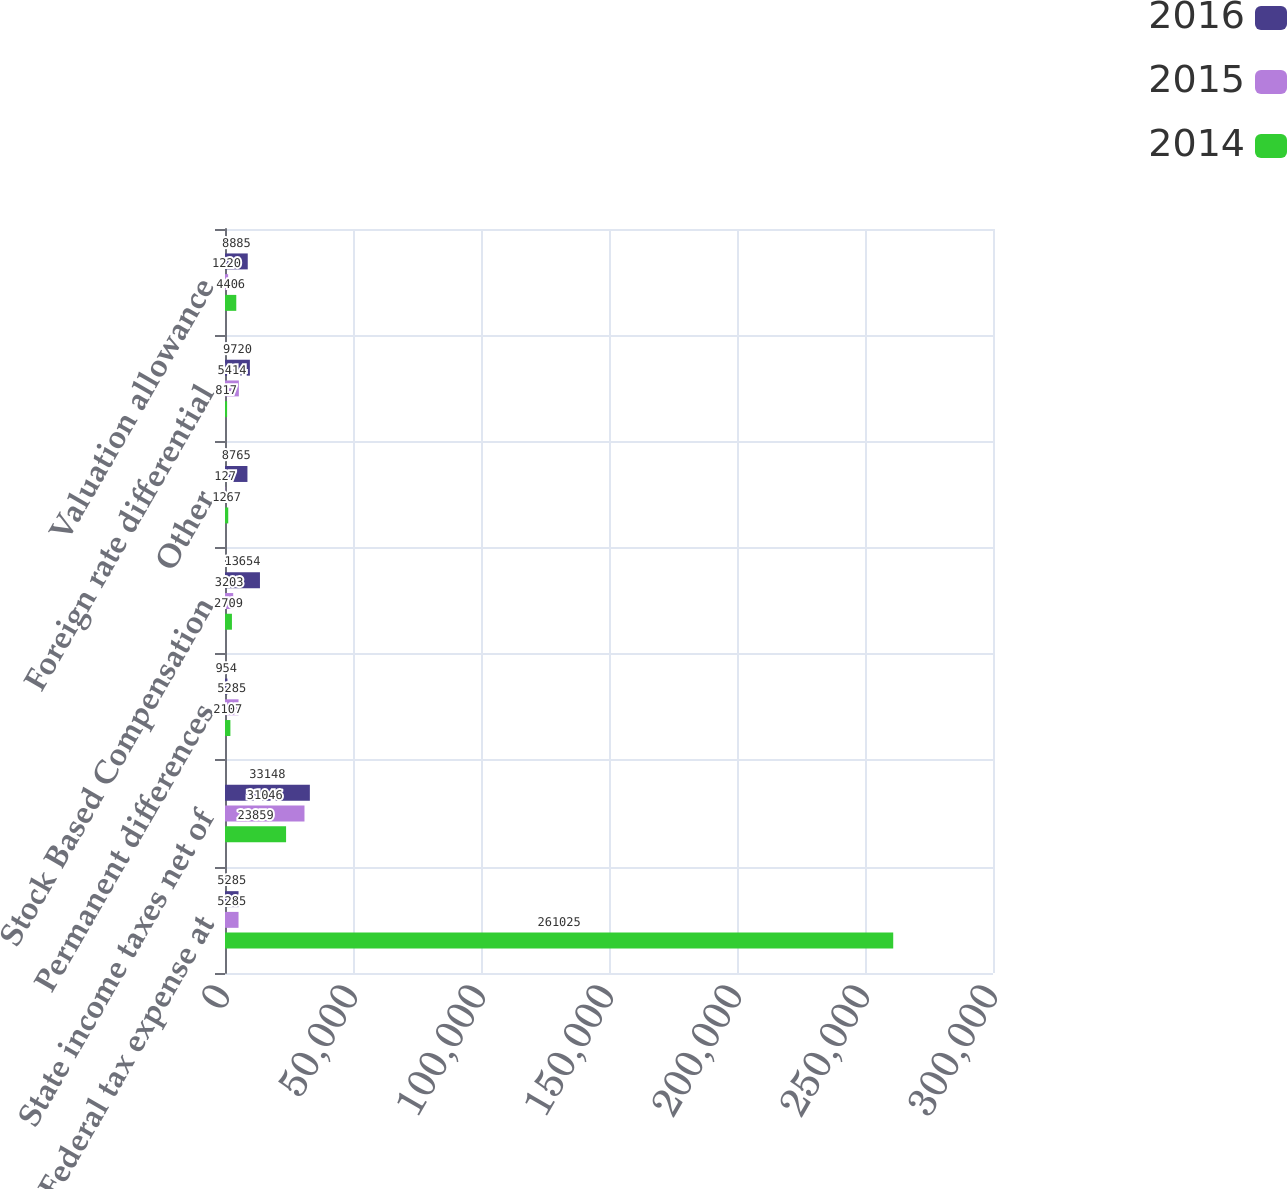Convert chart to OTSL. <chart><loc_0><loc_0><loc_500><loc_500><stacked_bar_chart><ecel><fcel>US Federal tax expense at<fcel>State income taxes net of<fcel>Permanent differences<fcel>Stock Based Compensation<fcel>Other<fcel>Foreign rate differential<fcel>Valuation allowance<nl><fcel>2016<fcel>5285<fcel>33148<fcel>954<fcel>13654<fcel>8765<fcel>9720<fcel>8885<nl><fcel>2015<fcel>5285<fcel>31046<fcel>5285<fcel>3203<fcel>127<fcel>5414<fcel>1220<nl><fcel>2014<fcel>261025<fcel>23859<fcel>2107<fcel>2709<fcel>1267<fcel>817<fcel>4406<nl></chart> 